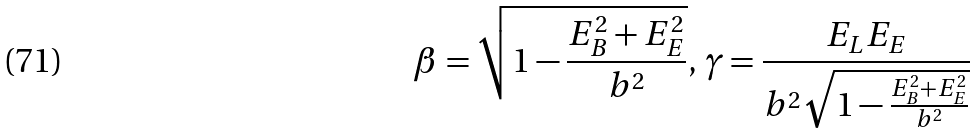Convert formula to latex. <formula><loc_0><loc_0><loc_500><loc_500>\beta = \sqrt { 1 - \frac { E _ { B } ^ { 2 } + E _ { E } ^ { 2 } } { b ^ { 2 } } } , \, \gamma = \frac { E _ { L } E _ { E } } { b ^ { 2 } \sqrt { 1 - \frac { E _ { B } ^ { 2 } + E _ { E } ^ { 2 } } { b ^ { 2 } } } }</formula> 